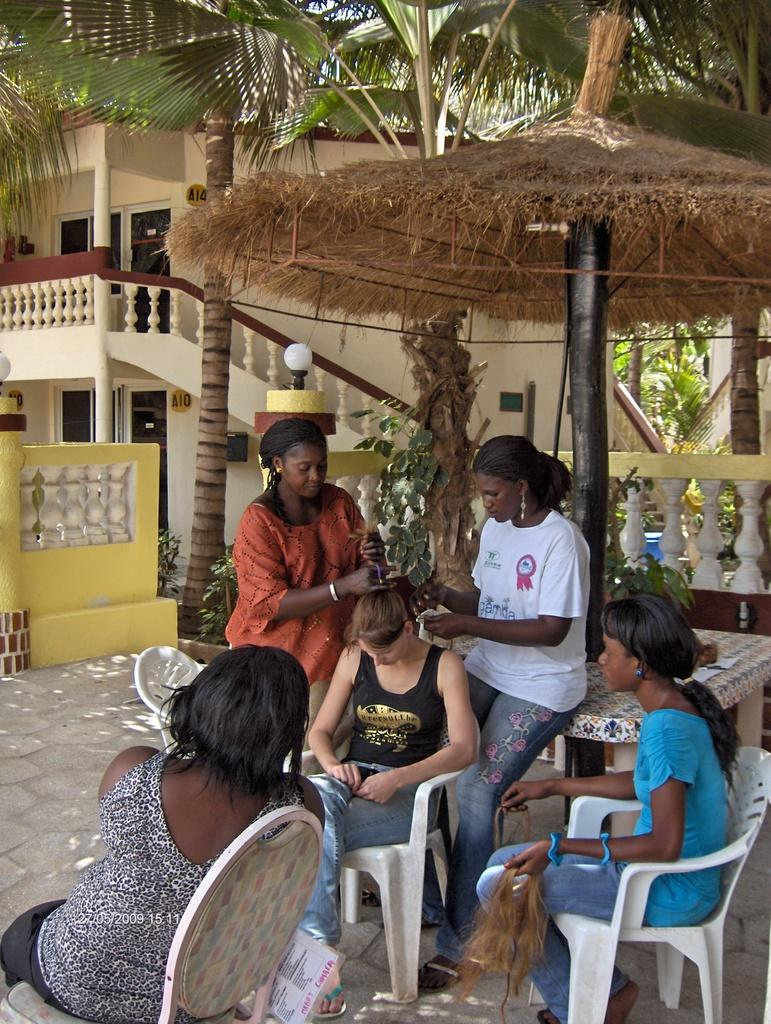What are the people in the image doing? There are people sitting and standing in the image. Can you describe the setting in which the people are located? To produce the conversation, we first identify the main subjects in the image, which are the people. We then describe their actions, noting that some are sitting while others are standing. Finally, we mention the background of the image, which includes a building. Absurd Question/Answer: What type of seed is being sold at the price mentioned in the image? There is no mention of seeds or prices in the image. Is there any blood visible on the people in the image? There is no blood visible on the people in the image. 